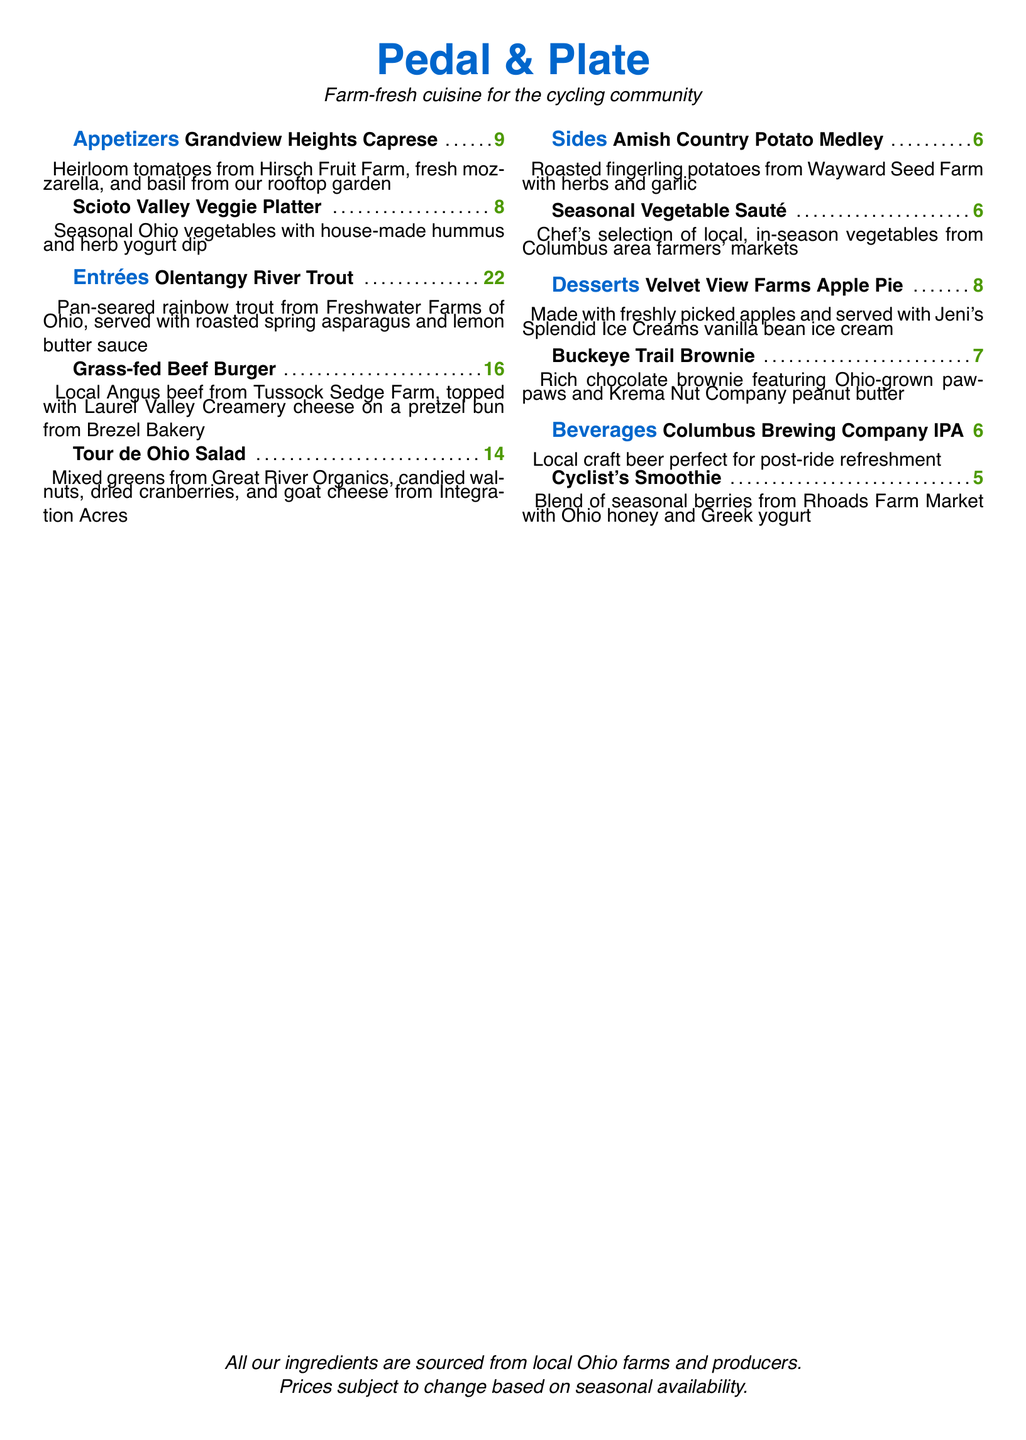What is the price of the Grandview Heights Caprese? The price for the Grandview Heights Caprese is listed next to the menu item.
Answer: 9 What farm provides the rainbow trout? The document mentions that the rainbow trout is from Freshwater Farms of Ohio.
Answer: Freshwater Farms of Ohio How many sides are listed on the menu? There are a total of two sides mentioned in the sides section of the menu.
Answer: 2 What type of cheese is used in the Grass-fed Beef Burger? The type of cheese for the Grass-fed Beef Burger is specified next to it in the menu.
Answer: Laurel Valley Creamery cheese Which dessert features Ohio-grown pawpaws? The dessert containing Ohio-grown pawpaws is explicitly stated in the dessert section.
Answer: Buckeye Trail Brownie What is the price of the Cyclist's Smoothie? The price for the Cyclist's Smoothie can be found in the beverages section.
Answer: 5 Identify a vegetable dish that is served with a dip. The menu describes a vegetable dish served with dips in the appetizers section.
Answer: Scioto Valley Veggie Platter Which dessert is made with freshly picked apples? The dessert that is made from freshly picked apples is clearly specified in the menu.
Answer: Velvet View Farms Apple Pie What type of beer is offered on the menu? The menu specifically describes the type of beer available among the beverages.
Answer: Columbus Brewing Company IPA 